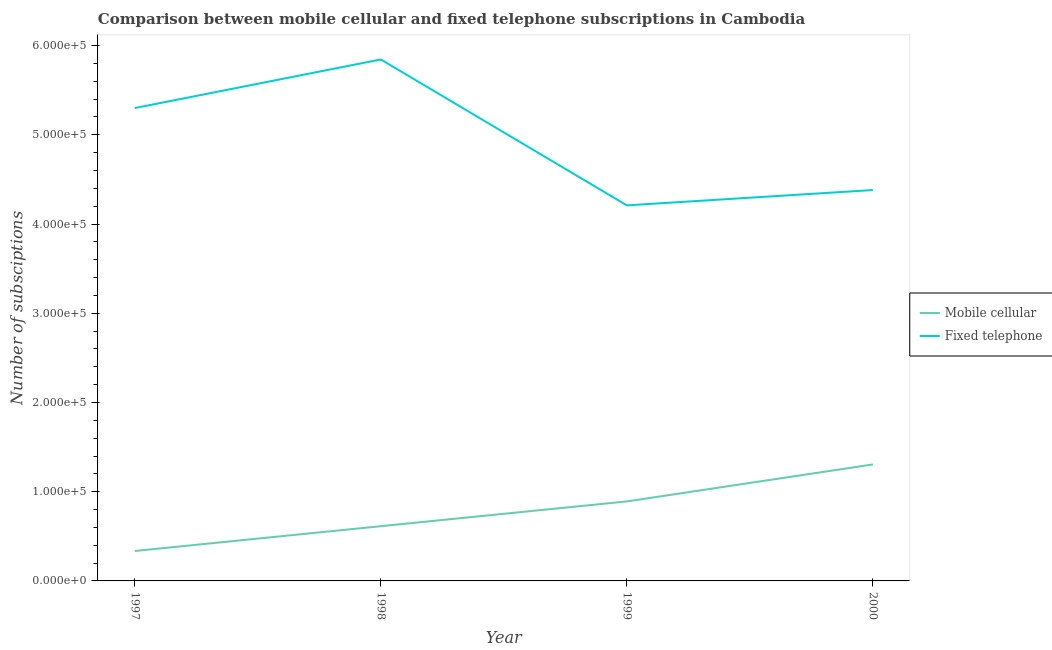Does the line corresponding to number of fixed telephone subscriptions intersect with the line corresponding to number of mobile cellular subscriptions?
Keep it short and to the point. No. What is the number of fixed telephone subscriptions in 2000?
Ensure brevity in your answer.  4.38e+05. Across all years, what is the maximum number of fixed telephone subscriptions?
Offer a very short reply. 5.84e+05. Across all years, what is the minimum number of fixed telephone subscriptions?
Your answer should be very brief. 4.21e+05. In which year was the number of mobile cellular subscriptions maximum?
Make the answer very short. 2000. What is the total number of fixed telephone subscriptions in the graph?
Offer a terse response. 1.97e+06. What is the difference between the number of fixed telephone subscriptions in 1997 and that in 1998?
Give a very brief answer. -5.45e+04. What is the difference between the number of mobile cellular subscriptions in 1998 and the number of fixed telephone subscriptions in 2000?
Your answer should be compact. -3.77e+05. What is the average number of mobile cellular subscriptions per year?
Give a very brief answer. 7.86e+04. In the year 1998, what is the difference between the number of fixed telephone subscriptions and number of mobile cellular subscriptions?
Make the answer very short. 5.23e+05. What is the ratio of the number of mobile cellular subscriptions in 1997 to that in 1999?
Provide a succinct answer. 0.38. Is the difference between the number of fixed telephone subscriptions in 1997 and 1999 greater than the difference between the number of mobile cellular subscriptions in 1997 and 1999?
Your answer should be compact. Yes. What is the difference between the highest and the second highest number of fixed telephone subscriptions?
Make the answer very short. 5.45e+04. What is the difference between the highest and the lowest number of fixed telephone subscriptions?
Ensure brevity in your answer.  1.64e+05. Is the sum of the number of fixed telephone subscriptions in 1997 and 2000 greater than the maximum number of mobile cellular subscriptions across all years?
Give a very brief answer. Yes. Does the number of mobile cellular subscriptions monotonically increase over the years?
Your response must be concise. Yes. Is the number of mobile cellular subscriptions strictly greater than the number of fixed telephone subscriptions over the years?
Your answer should be very brief. No. How many lines are there?
Offer a terse response. 2. How many years are there in the graph?
Your answer should be compact. 4. What is the difference between two consecutive major ticks on the Y-axis?
Your answer should be compact. 1.00e+05. Are the values on the major ticks of Y-axis written in scientific E-notation?
Give a very brief answer. Yes. Does the graph contain any zero values?
Offer a terse response. No. Where does the legend appear in the graph?
Give a very brief answer. Center right. What is the title of the graph?
Offer a very short reply. Comparison between mobile cellular and fixed telephone subscriptions in Cambodia. What is the label or title of the Y-axis?
Give a very brief answer. Number of subsciptions. What is the Number of subsciptions in Mobile cellular in 1997?
Ensure brevity in your answer.  3.36e+04. What is the Number of subsciptions of Fixed telephone in 1997?
Offer a very short reply. 5.30e+05. What is the Number of subsciptions of Mobile cellular in 1998?
Give a very brief answer. 6.13e+04. What is the Number of subsciptions in Fixed telephone in 1998?
Your response must be concise. 5.84e+05. What is the Number of subsciptions in Mobile cellular in 1999?
Ensure brevity in your answer.  8.91e+04. What is the Number of subsciptions in Fixed telephone in 1999?
Offer a very short reply. 4.21e+05. What is the Number of subsciptions in Mobile cellular in 2000?
Your response must be concise. 1.31e+05. What is the Number of subsciptions of Fixed telephone in 2000?
Keep it short and to the point. 4.38e+05. Across all years, what is the maximum Number of subsciptions in Mobile cellular?
Your answer should be very brief. 1.31e+05. Across all years, what is the maximum Number of subsciptions in Fixed telephone?
Ensure brevity in your answer.  5.84e+05. Across all years, what is the minimum Number of subsciptions in Mobile cellular?
Provide a succinct answer. 3.36e+04. Across all years, what is the minimum Number of subsciptions in Fixed telephone?
Make the answer very short. 4.21e+05. What is the total Number of subsciptions of Mobile cellular in the graph?
Make the answer very short. 3.15e+05. What is the total Number of subsciptions of Fixed telephone in the graph?
Your answer should be compact. 1.97e+06. What is the difference between the Number of subsciptions in Mobile cellular in 1997 and that in 1998?
Your answer should be compact. -2.78e+04. What is the difference between the Number of subsciptions in Fixed telephone in 1997 and that in 1998?
Keep it short and to the point. -5.45e+04. What is the difference between the Number of subsciptions in Mobile cellular in 1997 and that in 1999?
Offer a very short reply. -5.56e+04. What is the difference between the Number of subsciptions of Fixed telephone in 1997 and that in 1999?
Offer a terse response. 1.09e+05. What is the difference between the Number of subsciptions of Mobile cellular in 1997 and that in 2000?
Your answer should be compact. -9.70e+04. What is the difference between the Number of subsciptions in Fixed telephone in 1997 and that in 2000?
Your answer should be very brief. 9.19e+04. What is the difference between the Number of subsciptions in Mobile cellular in 1998 and that in 1999?
Provide a short and direct response. -2.78e+04. What is the difference between the Number of subsciptions of Fixed telephone in 1998 and that in 1999?
Offer a terse response. 1.64e+05. What is the difference between the Number of subsciptions of Mobile cellular in 1998 and that in 2000?
Ensure brevity in your answer.  -6.92e+04. What is the difference between the Number of subsciptions in Fixed telephone in 1998 and that in 2000?
Keep it short and to the point. 1.46e+05. What is the difference between the Number of subsciptions in Mobile cellular in 1999 and that in 2000?
Offer a terse response. -4.14e+04. What is the difference between the Number of subsciptions of Fixed telephone in 1999 and that in 2000?
Your response must be concise. -1.72e+04. What is the difference between the Number of subsciptions in Mobile cellular in 1997 and the Number of subsciptions in Fixed telephone in 1998?
Ensure brevity in your answer.  -5.51e+05. What is the difference between the Number of subsciptions in Mobile cellular in 1997 and the Number of subsciptions in Fixed telephone in 1999?
Provide a short and direct response. -3.87e+05. What is the difference between the Number of subsciptions of Mobile cellular in 1997 and the Number of subsciptions of Fixed telephone in 2000?
Keep it short and to the point. -4.05e+05. What is the difference between the Number of subsciptions of Mobile cellular in 1998 and the Number of subsciptions of Fixed telephone in 1999?
Offer a terse response. -3.60e+05. What is the difference between the Number of subsciptions in Mobile cellular in 1998 and the Number of subsciptions in Fixed telephone in 2000?
Make the answer very short. -3.77e+05. What is the difference between the Number of subsciptions of Mobile cellular in 1999 and the Number of subsciptions of Fixed telephone in 2000?
Offer a very short reply. -3.49e+05. What is the average Number of subsciptions in Mobile cellular per year?
Your answer should be compact. 7.86e+04. What is the average Number of subsciptions in Fixed telephone per year?
Provide a succinct answer. 4.93e+05. In the year 1997, what is the difference between the Number of subsciptions of Mobile cellular and Number of subsciptions of Fixed telephone?
Provide a short and direct response. -4.96e+05. In the year 1998, what is the difference between the Number of subsciptions in Mobile cellular and Number of subsciptions in Fixed telephone?
Your response must be concise. -5.23e+05. In the year 1999, what is the difference between the Number of subsciptions in Mobile cellular and Number of subsciptions in Fixed telephone?
Make the answer very short. -3.32e+05. In the year 2000, what is the difference between the Number of subsciptions of Mobile cellular and Number of subsciptions of Fixed telephone?
Your answer should be compact. -3.08e+05. What is the ratio of the Number of subsciptions of Mobile cellular in 1997 to that in 1998?
Provide a short and direct response. 0.55. What is the ratio of the Number of subsciptions of Fixed telephone in 1997 to that in 1998?
Provide a short and direct response. 0.91. What is the ratio of the Number of subsciptions of Mobile cellular in 1997 to that in 1999?
Offer a very short reply. 0.38. What is the ratio of the Number of subsciptions in Fixed telephone in 1997 to that in 1999?
Your response must be concise. 1.26. What is the ratio of the Number of subsciptions in Mobile cellular in 1997 to that in 2000?
Provide a short and direct response. 0.26. What is the ratio of the Number of subsciptions of Fixed telephone in 1997 to that in 2000?
Provide a short and direct response. 1.21. What is the ratio of the Number of subsciptions of Mobile cellular in 1998 to that in 1999?
Offer a terse response. 0.69. What is the ratio of the Number of subsciptions of Fixed telephone in 1998 to that in 1999?
Your answer should be compact. 1.39. What is the ratio of the Number of subsciptions of Mobile cellular in 1998 to that in 2000?
Provide a succinct answer. 0.47. What is the ratio of the Number of subsciptions in Fixed telephone in 1998 to that in 2000?
Offer a very short reply. 1.33. What is the ratio of the Number of subsciptions of Mobile cellular in 1999 to that in 2000?
Provide a succinct answer. 0.68. What is the ratio of the Number of subsciptions in Fixed telephone in 1999 to that in 2000?
Offer a very short reply. 0.96. What is the difference between the highest and the second highest Number of subsciptions in Mobile cellular?
Provide a succinct answer. 4.14e+04. What is the difference between the highest and the second highest Number of subsciptions of Fixed telephone?
Provide a short and direct response. 5.45e+04. What is the difference between the highest and the lowest Number of subsciptions in Mobile cellular?
Keep it short and to the point. 9.70e+04. What is the difference between the highest and the lowest Number of subsciptions in Fixed telephone?
Give a very brief answer. 1.64e+05. 